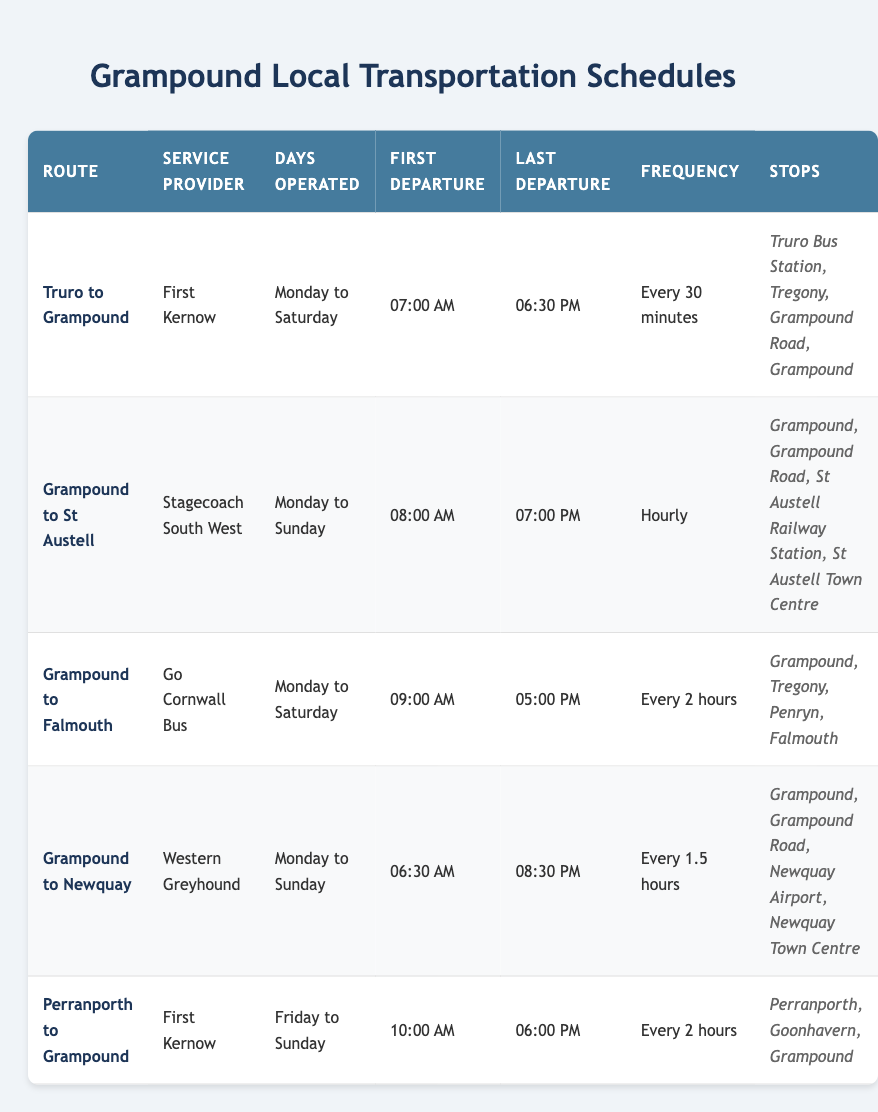What is the first departure time for the Grampound to St Austell route? The table lists the first departure time for the Grampound to St Austell route as "08:00 AM."
Answer: 08:00 AM How many days a week does the Grampound to Falmouth bus operate? According to the table, the Grampound to Falmouth bus operates from Monday to Saturday, which is 6 days a week.
Answer: 6 days What is the frequency of the bus service from Truro to Grampound? The table states that the frequency for the Truro to Grampound route is "Every 30 minutes."
Answer: Every 30 minutes Does the Grampound to Newquay route operate on weekends? The Grampound to Newquay service operates on "Monday to Sunday," which confirms it operates on weekends.
Answer: Yes What is the total number of stops for the Grampound to St Austell route? The stops listed for the Grampound to St Austell route are Grampound, Grampound Road, St Austell Railway Station, and St Austell Town Centre, totaling 4 stops.
Answer: 4 stops Which route has the latest last departure time? By reviewing the last departure times, the Grampound to Newquay route has the latest departure time of "08:30 PM."
Answer: 08:30 PM How many routes operate every day of the week? The Grampound to St Austell and Grampound to Newquay routes operate every day, which totals 2 routes.
Answer: 2 routes If a person wants to travel from Grampound to Falmouth, what is the frequency of the bus service? The Grampound to Falmouth bus service operates at a frequency of "Every 2 hours," as stated in the table.
Answer: Every 2 hours Which service provider operates the route from Perranporth to Grampound? The table indicates that the provider for the Perranporth to Grampound route is "First Kernow."
Answer: First Kernow If a bus from Grampound to Newquay leaves at 08:30 AM, how long until the next bus departs? The frequency of the Grampound to Newquay route is "Every 1.5 hours." If a bus departs at 08:30 AM, the next one would leave at 10:00 AM, which is 1 hour and 30 minutes later.
Answer: 1 hour and 30 minutes How many more hours does the Grampound to St Austell bus operate compared to the Grampound to Falmouth service on Monday? The Grampound to St Austell bus operates for 11 hours (08:00 AM to 07:00 PM) and the Grampound to Falmouth bus operates for 8 hours (09:00 AM to 05:00 PM) for a difference of 3 hours.
Answer: 3 hours 